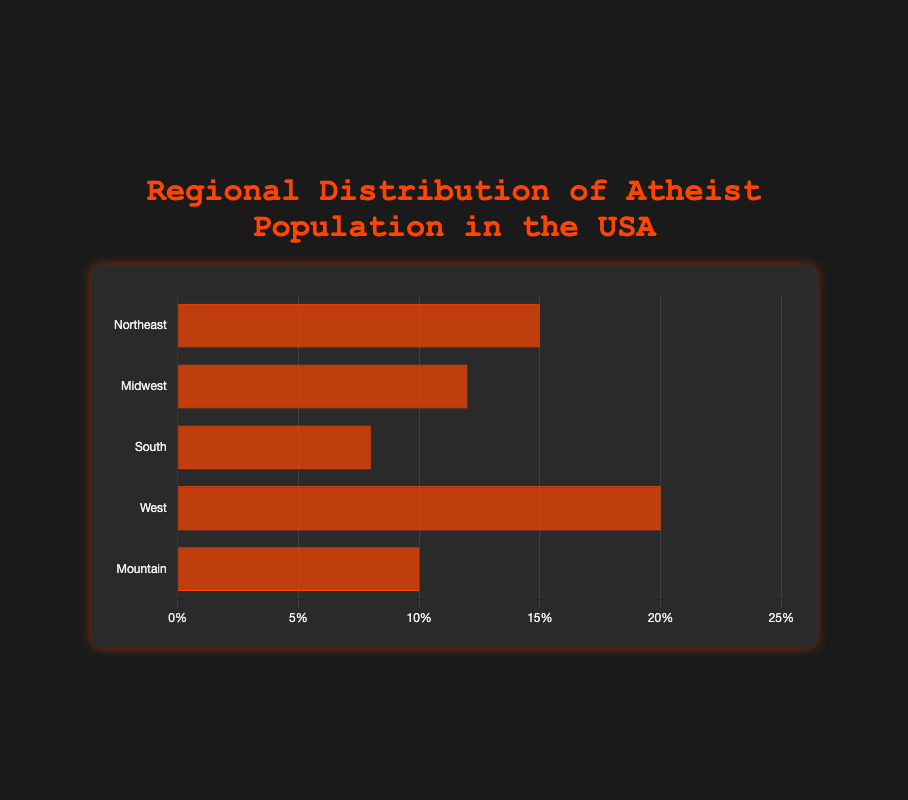Which region has the highest percentage of the atheist population? Look at the bar with the greatest length. The region with the largest percentage is the West with 20%.
Answer: West Which region has the lowest percentage of the atheist population? Identify the shortest bar in the chart. The South region has the lowest percentage at 8%.
Answer: South How much greater is the atheist population percentage in the West compared to the South? To find the difference, subtract the South's percentage (8%) from the West's percentage (20%). 20% - 8% = 12%.
Answer: 12% Combine the atheist populations in the Northeast and Midwest; how do they compare to the atheist population in the West? Add the percentages for Northeast (15%) and Midwest (12%) to get 27%. Compare this to the West's 20%. 27% is greater than 20%.
Answer: 27% > 20% What is the average percentage of atheists across all regions? Add all the percentages (15%, 12%, 8%, 20%, 10%) and divide by the number of regions (5). (15 + 12 + 8 + 20 + 10) / 5 = 65 / 5 = 13%.
Answer: 13% Rank the regions by the percentage of the atheist population from highest to lowest. Order the regions by the length of the bars. The order is West (20%), Northeast (15%), Midwest (12%), Mountain (10%), and South (8%).
Answer: West, Northeast, Midwest, Mountain, South Is the percentage of atheists in the Midwest closer to the South or the Northeast? Calculate the difference between Midwest (12%) and South (8%), as well as Midwest (12%) and Northeast (15%). 12% - 8% = 4% and 15% - 12% = 3%. The Midwest is closer to the Northeast.
Answer: Northeast Which regions together make up the majority of the atheist population? Identify the highest percentage regions and sum until you exceed 50%. West (20%) + Northeast (15%) + Midwest (12%) = 47%. Adding Mountain (10%) results in 57%, which exceeds 50%. Regions are West, Northeast, Midwest, and Mountain.
Answer: West, Northeast, Midwest, Mountain What additional information is provided when hovering over a bar on the chart? Hovering over a bar provides the names of the states included in that region. For instance, the West shows California, Washington, Oregon, and Colorado.
Answer: States in each region 